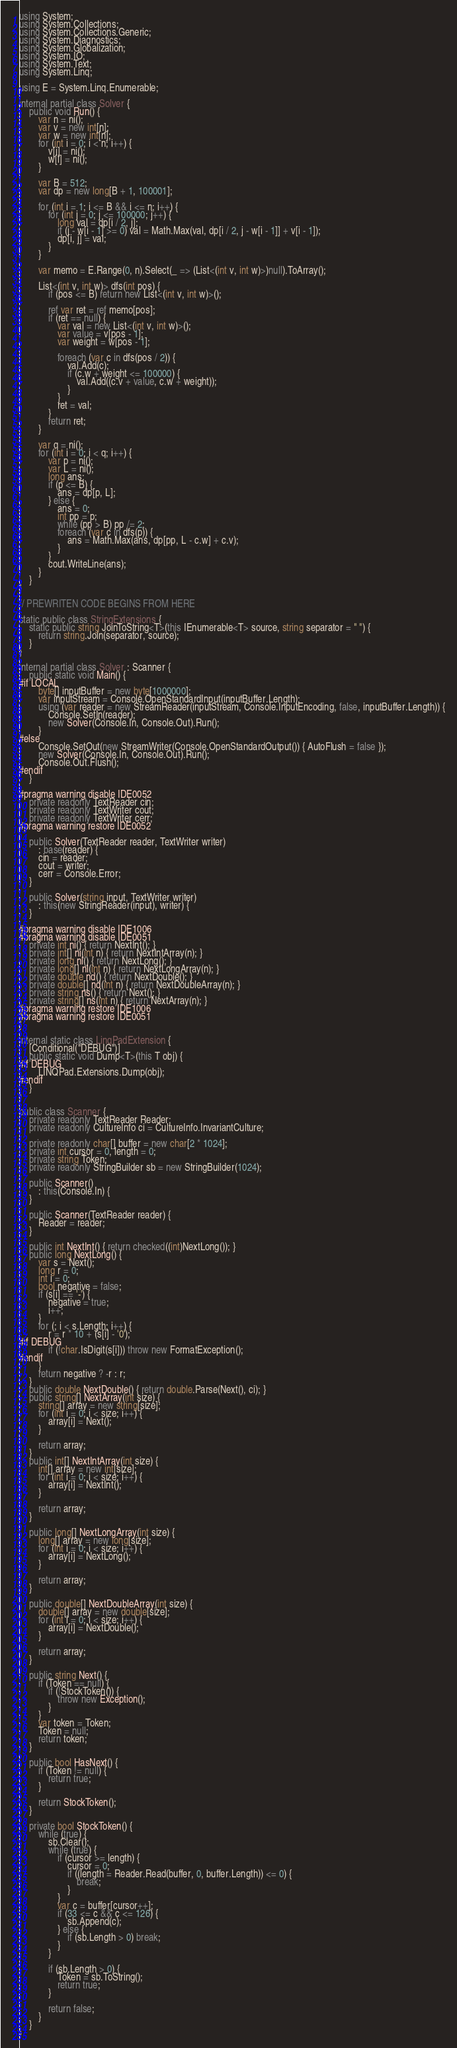<code> <loc_0><loc_0><loc_500><loc_500><_C#_>using System;
using System.Collections;
using System.Collections.Generic;
using System.Diagnostics;
using System.Globalization;
using System.IO;
using System.Text;
using System.Linq;

using E = System.Linq.Enumerable;

internal partial class Solver {
    public void Run() {
        var n = ni();
        var v = new int[n];
        var w = new int[n];
        for (int i = 0; i < n; i++) {
            v[i] = ni();
            w[i] = ni();
        }

        var B = 512;
        var dp = new long[B + 1, 100001];

        for (int i = 1; i <= B && i <= n; i++) {
            for (int j = 0; j <= 100000; j++) {
                long val = dp[i / 2, j];
                if (j - w[i - 1] >= 0) val = Math.Max(val, dp[i / 2, j - w[i - 1]] + v[i - 1]);
                dp[i, j] = val;
            }
        }

        var memo = E.Range(0, n).Select(_ => (List<(int v, int w)>)null).ToArray();

        List<(int v, int w)> dfs(int pos) {
            if (pos <= B) return new List<(int v, int w)>();

            ref var ret = ref memo[pos];
            if (ret == null) {
                var val = new List<(int v, int w)>();
                var value = v[pos - 1];
                var weight = w[pos - 1];

                foreach (var c in dfs(pos / 2)) {
                    val.Add(c);
                    if (c.w + weight <= 100000) {
                        val.Add((c.v + value, c.w + weight));
                    }
                }
                ret = val;
            }
            return ret;
        }

        var q = ni();
        for (int i = 0; i < q; i++) {
            var p = ni();
            var L = ni();
            long ans;
            if (p <= B) {
                ans = dp[p, L];
            } else {
                ans = 0;
                int pp = p;
                while (pp > B) pp /= 2;
                foreach (var c in dfs(p)) {
                    ans = Math.Max(ans, dp[pp, L - c.w] + c.v);
                }
            }
            cout.WriteLine(ans);
        }
    }
}

// PREWRITEN CODE BEGINS FROM HERE

static public class StringExtensions {
    static public string JoinToString<T>(this IEnumerable<T> source, string separator = " ") {
        return string.Join(separator, source);
    }
}

internal partial class Solver : Scanner {
    public static void Main() {
#if LOCAL
        byte[] inputBuffer = new byte[1000000];
        var inputStream = Console.OpenStandardInput(inputBuffer.Length);
        using (var reader = new StreamReader(inputStream, Console.InputEncoding, false, inputBuffer.Length)) {
            Console.SetIn(reader);
            new Solver(Console.In, Console.Out).Run();
        }
#else
        Console.SetOut(new StreamWriter(Console.OpenStandardOutput()) { AutoFlush = false });
        new Solver(Console.In, Console.Out).Run();
        Console.Out.Flush();
#endif
    }

#pragma warning disable IDE0052
    private readonly TextReader cin;
    private readonly TextWriter cout;
    private readonly TextWriter cerr;
#pragma warning restore IDE0052

    public Solver(TextReader reader, TextWriter writer)
        : base(reader) {
        cin = reader;
        cout = writer;
        cerr = Console.Error;
    }

    public Solver(string input, TextWriter writer)
        : this(new StringReader(input), writer) {
    }

#pragma warning disable IDE1006
#pragma warning disable IDE0051
    private int ni() { return NextInt(); }
    private int[] ni(int n) { return NextIntArray(n); }
    private long nl() { return NextLong(); }
    private long[] nl(int n) { return NextLongArray(n); }
    private double nd() { return NextDouble(); }
    private double[] nd(int n) { return NextDoubleArray(n); }
    private string ns() { return Next(); }
    private string[] ns(int n) { return NextArray(n); }
#pragma warning restore IDE1006
#pragma warning restore IDE0051
}

internal static class LinqPadExtension {
    [Conditional("DEBUG")]
    public static void Dump<T>(this T obj) {
#if DEBUG
        LINQPad.Extensions.Dump(obj);
#endif
    }
}

public class Scanner {
    private readonly TextReader Reader;
    private readonly CultureInfo ci = CultureInfo.InvariantCulture;

    private readonly char[] buffer = new char[2 * 1024];
    private int cursor = 0, length = 0;
    private string Token;
    private readonly StringBuilder sb = new StringBuilder(1024);

    public Scanner()
        : this(Console.In) {
    }

    public Scanner(TextReader reader) {
        Reader = reader;
    }

    public int NextInt() { return checked((int)NextLong()); }
    public long NextLong() {
        var s = Next();
        long r = 0;
        int i = 0;
        bool negative = false;
        if (s[i] == '-') {
            negative = true;
            i++;
        }
        for (; i < s.Length; i++) {
            r = r * 10 + (s[i] - '0');
#if DEBUG
            if (!char.IsDigit(s[i])) throw new FormatException();
#endif
        }
        return negative ? -r : r;
    }
    public double NextDouble() { return double.Parse(Next(), ci); }
    public string[] NextArray(int size) {
        string[] array = new string[size];
        for (int i = 0; i < size; i++) {
            array[i] = Next();
        }

        return array;
    }
    public int[] NextIntArray(int size) {
        int[] array = new int[size];
        for (int i = 0; i < size; i++) {
            array[i] = NextInt();
        }

        return array;
    }

    public long[] NextLongArray(int size) {
        long[] array = new long[size];
        for (int i = 0; i < size; i++) {
            array[i] = NextLong();
        }

        return array;
    }

    public double[] NextDoubleArray(int size) {
        double[] array = new double[size];
        for (int i = 0; i < size; i++) {
            array[i] = NextDouble();
        }

        return array;
    }

    public string Next() {
        if (Token == null) {
            if (!StockToken()) {
                throw new Exception();
            }
        }
        var token = Token;
        Token = null;
        return token;
    }

    public bool HasNext() {
        if (Token != null) {
            return true;
        }

        return StockToken();
    }

    private bool StockToken() {
        while (true) {
            sb.Clear();
            while (true) {
                if (cursor >= length) {
                    cursor = 0;
                    if ((length = Reader.Read(buffer, 0, buffer.Length)) <= 0) {
                        break;
                    }
                }
                var c = buffer[cursor++];
                if (33 <= c && c <= 126) {
                    sb.Append(c);
                } else {
                    if (sb.Length > 0) break;
                }
            }

            if (sb.Length > 0) {
                Token = sb.ToString();
                return true;
            }

            return false;
        }
    }
}</code> 